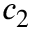Convert formula to latex. <formula><loc_0><loc_0><loc_500><loc_500>c _ { 2 }</formula> 